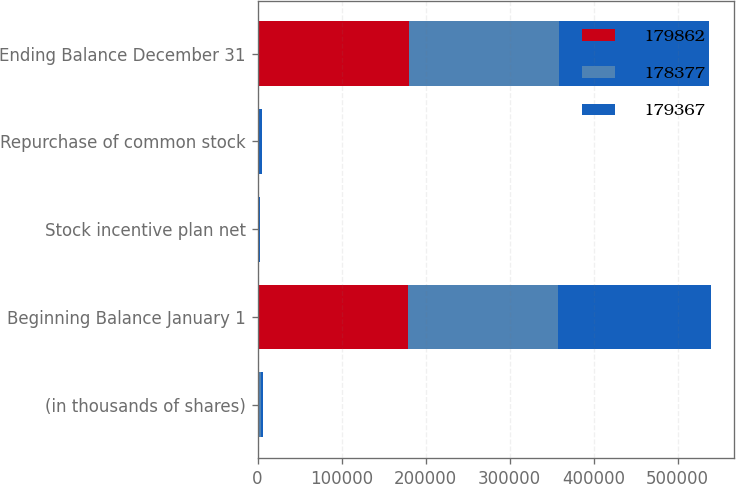Convert chart. <chart><loc_0><loc_0><loc_500><loc_500><stacked_bar_chart><ecel><fcel>(in thousands of shares)<fcel>Beginning Balance January 1<fcel>Stock incentive plan net<fcel>Repurchase of common stock<fcel>Ending Balance December 31<nl><fcel>179862<fcel>2017<fcel>179367<fcel>985<fcel>490<fcel>179862<nl><fcel>178377<fcel>2016<fcel>178377<fcel>1085<fcel>95<fcel>179367<nl><fcel>179367<fcel>2015<fcel>182300<fcel>1280<fcel>5203<fcel>178377<nl></chart> 